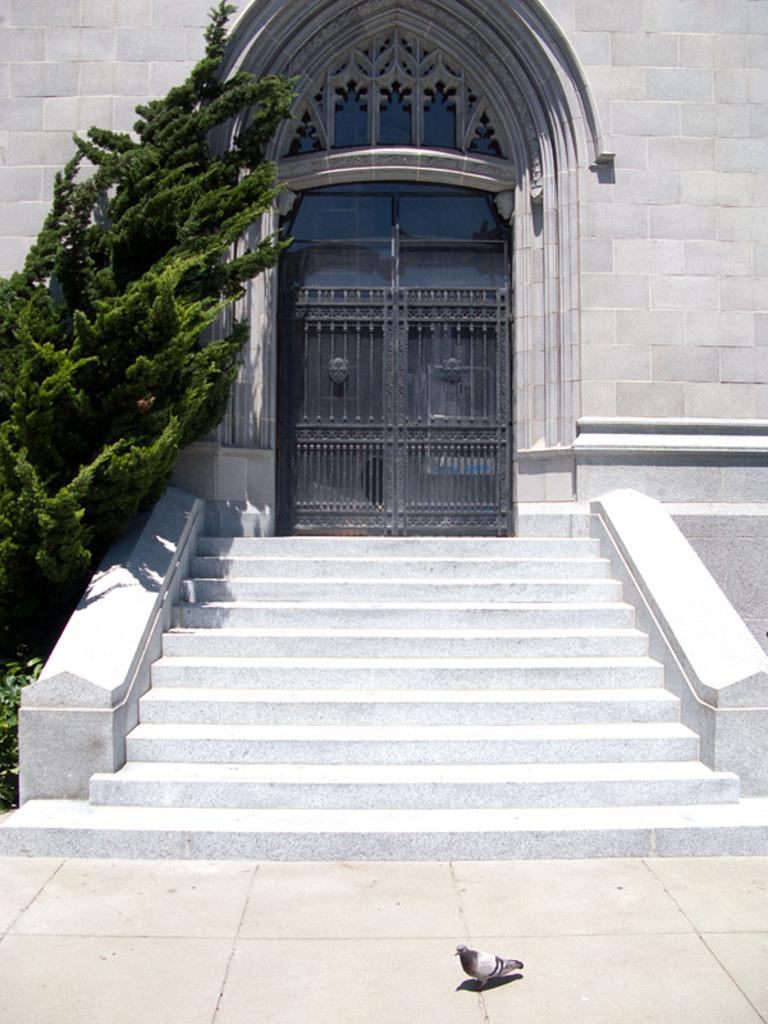What type of structure is present in the image? There is a building in the image. Are there any architectural features visible in the image? Yes, there are stairs in the image. What type of vegetation can be seen in the image? There is a tree and plants in the image. What animal is present on the ground in the image? There is a bird on the ground in the image. How many snails can be seen crawling on the hall in the image? There is no hall or snails present in the image. 